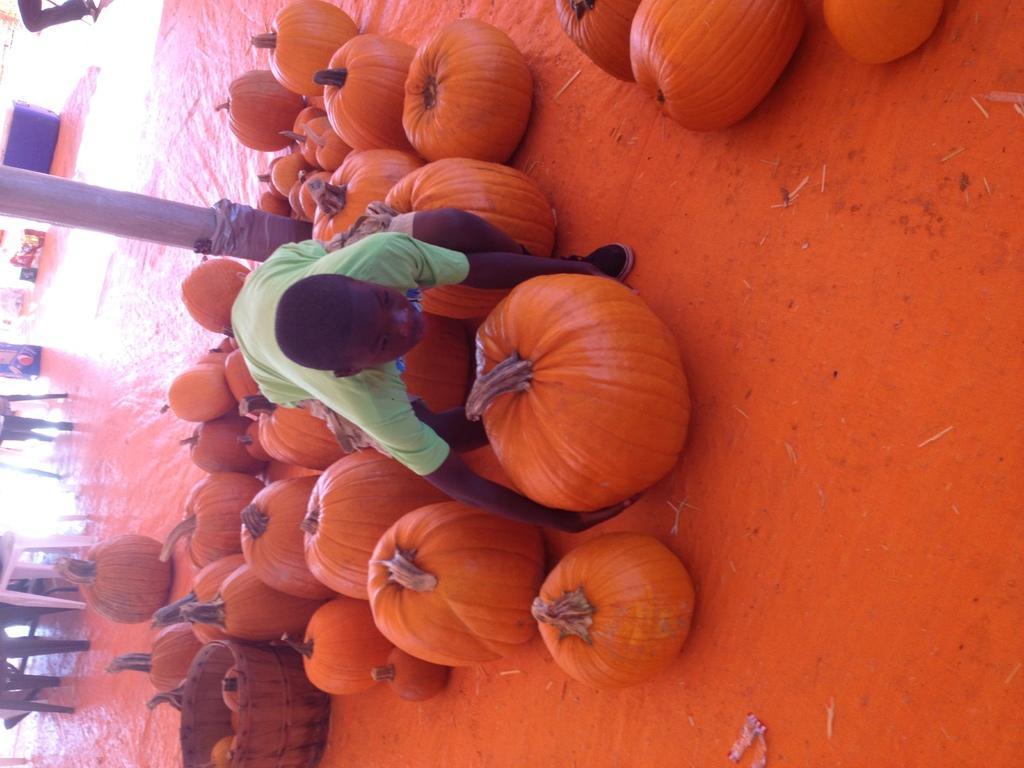How would you summarize this image in a sentence or two? In this image I can see number of orange colour pumpkins, a container, few chairs and here I can see a person in green colour dress. 